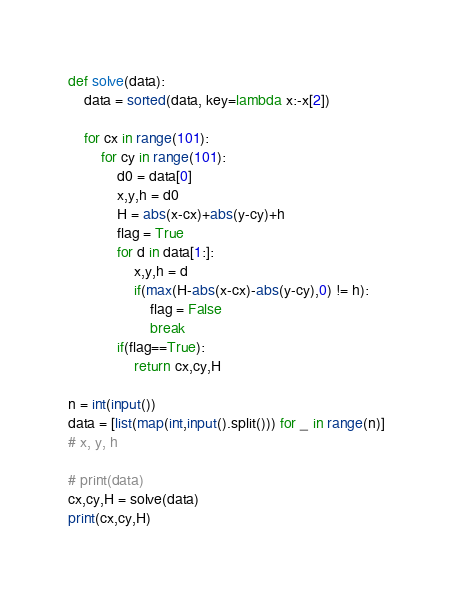<code> <loc_0><loc_0><loc_500><loc_500><_Python_>
def solve(data):
    data = sorted(data, key=lambda x:-x[2])

    for cx in range(101):
        for cy in range(101):
            d0 = data[0]
            x,y,h = d0
            H = abs(x-cx)+abs(y-cy)+h
            flag = True
            for d in data[1:]:
                x,y,h = d
                if(max(H-abs(x-cx)-abs(y-cy),0) != h):
                    flag = False
                    break
            if(flag==True):
                return cx,cy,H

n = int(input())
data = [list(map(int,input().split())) for _ in range(n)]
# x, y, h

# print(data)
cx,cy,H = solve(data)
print(cx,cy,H)</code> 